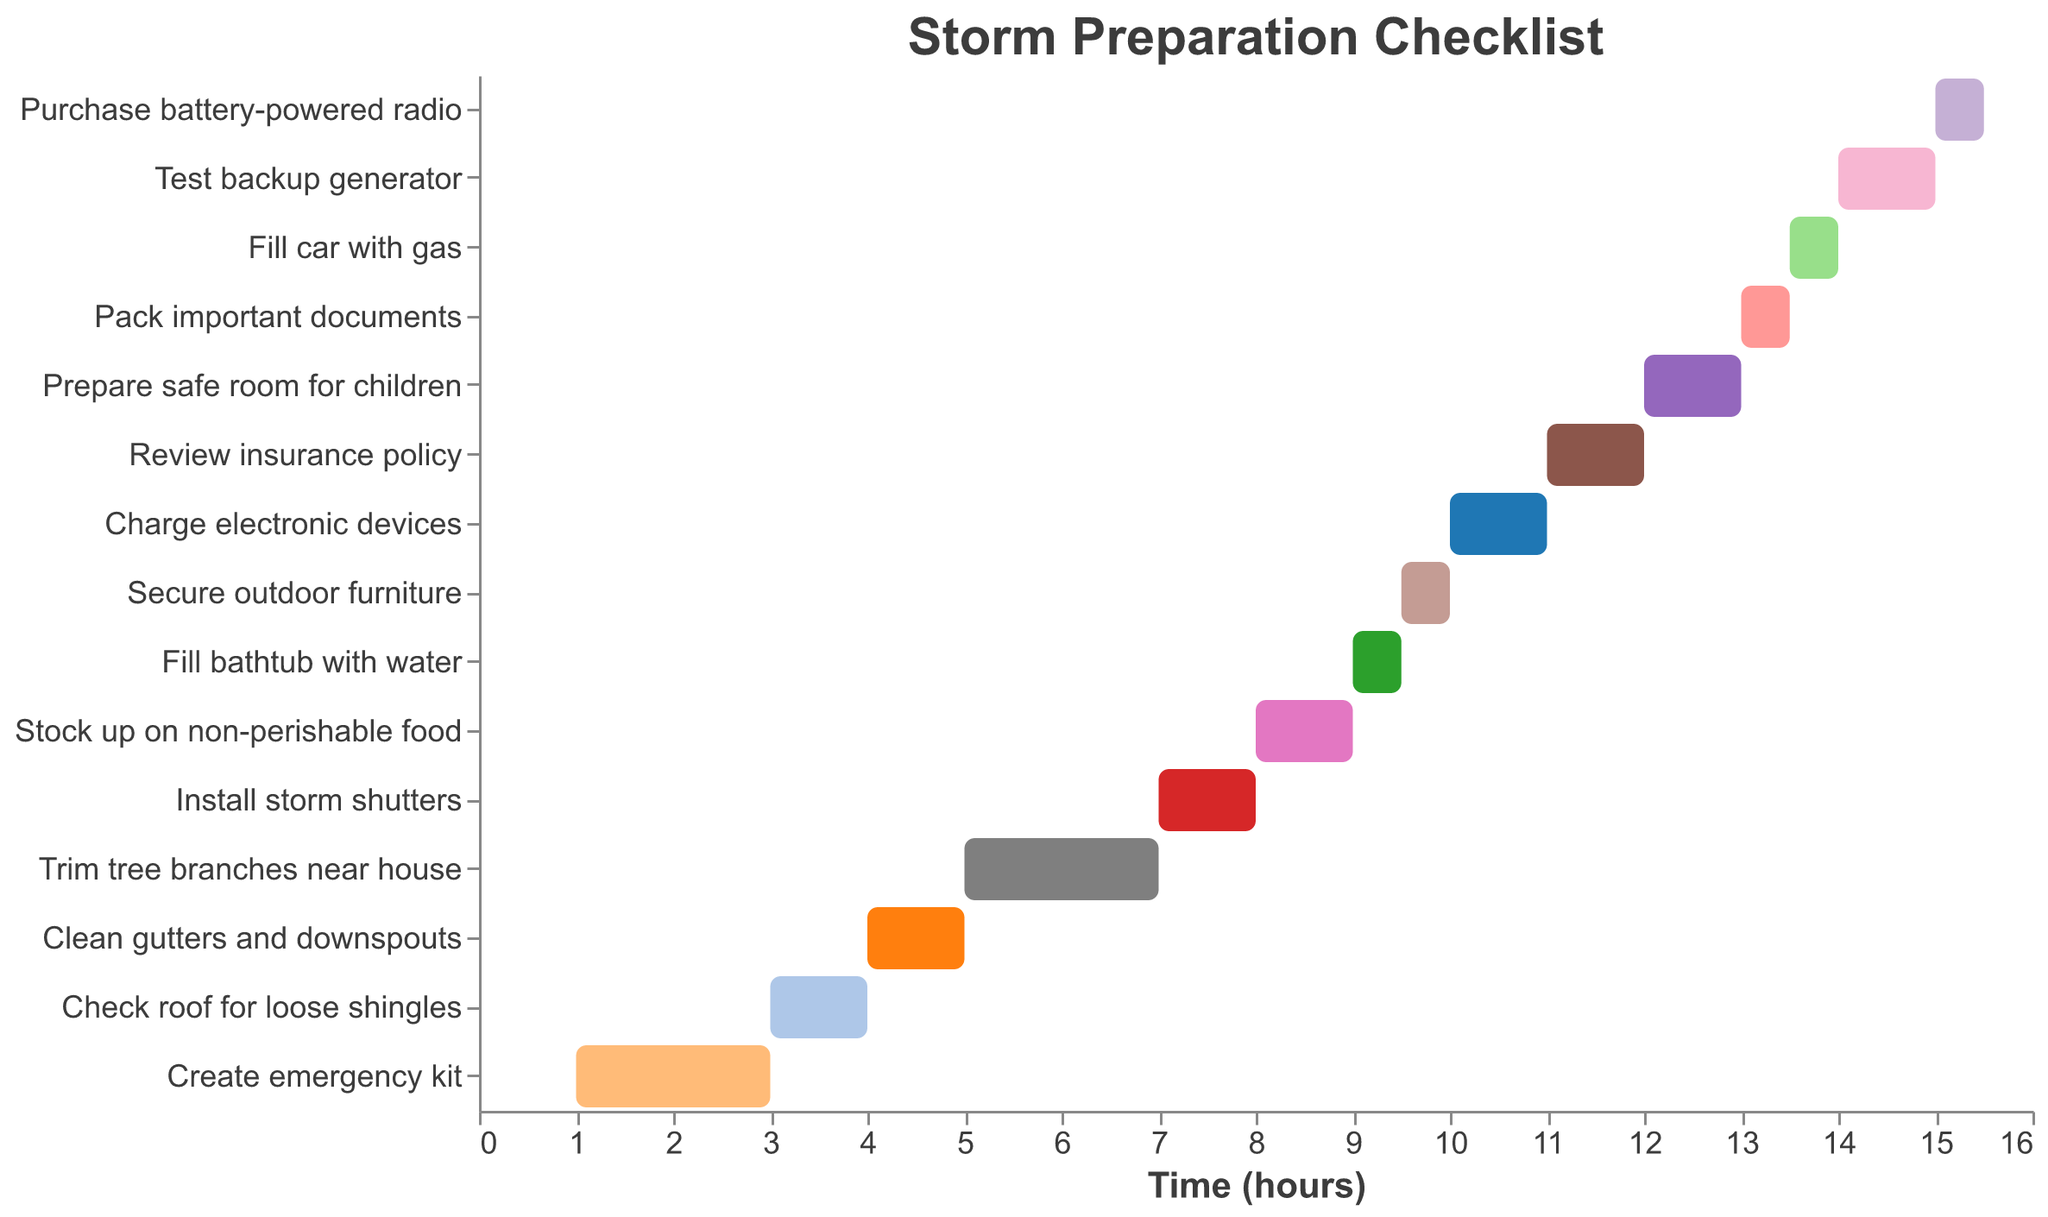What is the title of the chart? The title of the chart can be found at the top, it's bold and larger in font size.
Answer: Storm Preparation Checklist Which task takes the longest time to complete? You can compare the duration of all tasks and see that the longest bar represents the task that takes the most time.
Answer: Create emergency kit How many tasks start on the 9th hour? Count the tasks that have the start time listed as 9.
Answer: 3 What's the total duration of all tasks combined? Add up the duration of all tasks: 2+1+1+2+1+1+0.5+0.5+1+1+1+0.5+0.5+1+0.5 = 14.5 hours
Answer: 14.5 hours Which task comes after cleaning the gutters and downspouts? Look for the task that has a start time immediately following the end time of the "Clean gutters and downspouts" task, which ends at 5 hours.
Answer: Trim tree branches near house When does the task "Test backup generator" start and end? Check the start time and duration for this task in the chart: Starts at 14 and lasts for 1 hour. So, it ends at 14 + 1 = 15 hours.
Answer: 14 to 15 hours What task starts 0.5 hours after "Fill bathtub with water"? Find the task that begins 0.5 hours after the start time of "Fill bathtub with water," which starts at 9 and lasts 0.5 hours, thus ending at 9.5.
Answer: Secure outdoor furniture Which tasks are scheduled for the 8th hour and how long do they take? Identify the tasks that have a start time of 8, check their durations to see how long these tasks take.
Answer: Stock up on non-perishable food, 1 hour What is the final task on the list, and how long does it take? The last task in the data should be checked along with its duration.
Answer: Purchase battery-powered radio, 0.5 hours Which task happens right before "Charge electronic devices"? Look for the task that ends just before the start time of "Charge electronic devices" which begins at 10.
Answer: Secure outdoor furniture 